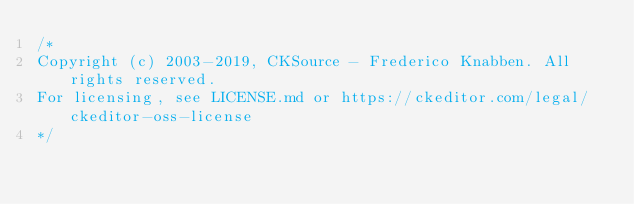<code> <loc_0><loc_0><loc_500><loc_500><_CSS_>/*
Copyright (c) 2003-2019, CKSource - Frederico Knabben. All rights reserved.
For licensing, see LICENSE.md or https://ckeditor.com/legal/ckeditor-oss-license
*/</code> 